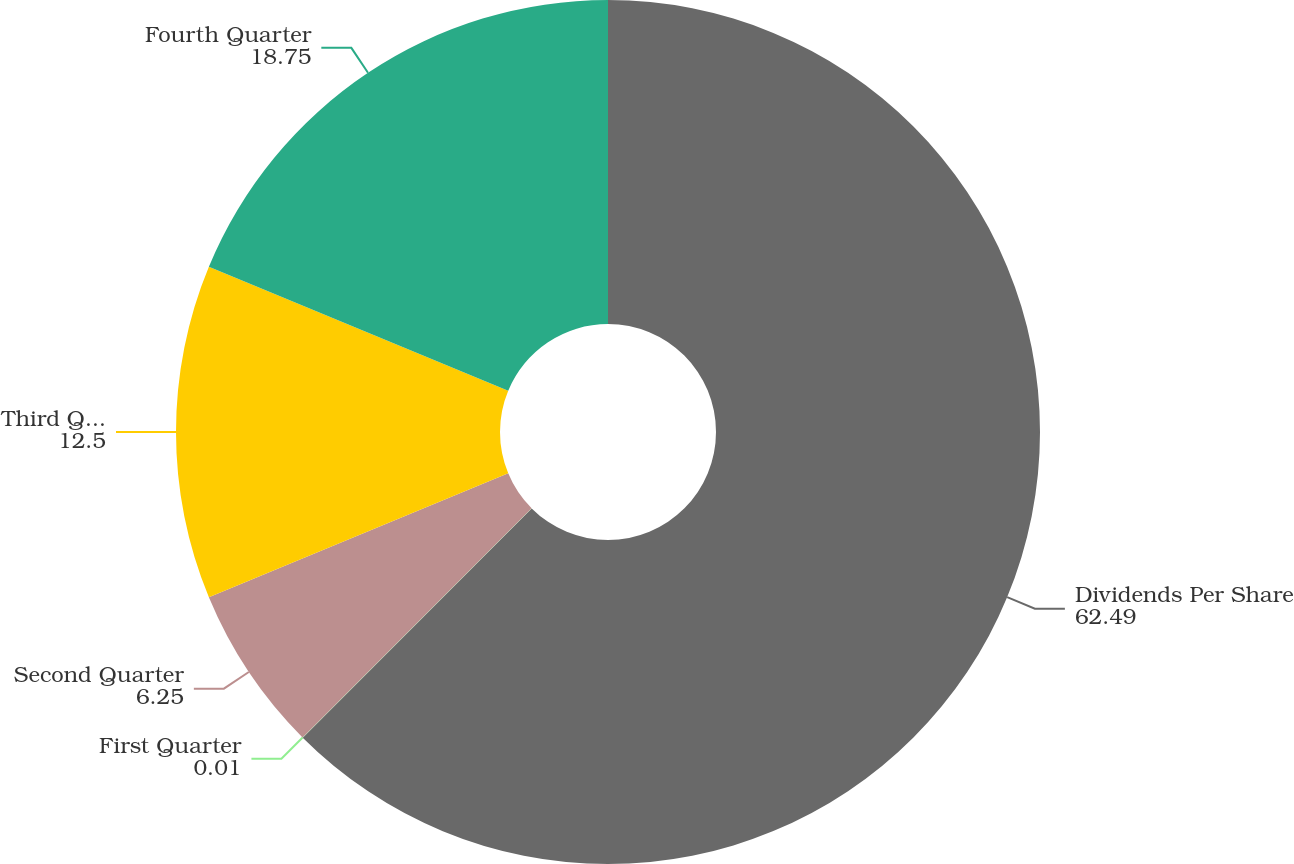Convert chart. <chart><loc_0><loc_0><loc_500><loc_500><pie_chart><fcel>Dividends Per Share<fcel>First Quarter<fcel>Second Quarter<fcel>Third Quarter<fcel>Fourth Quarter<nl><fcel>62.49%<fcel>0.01%<fcel>6.25%<fcel>12.5%<fcel>18.75%<nl></chart> 